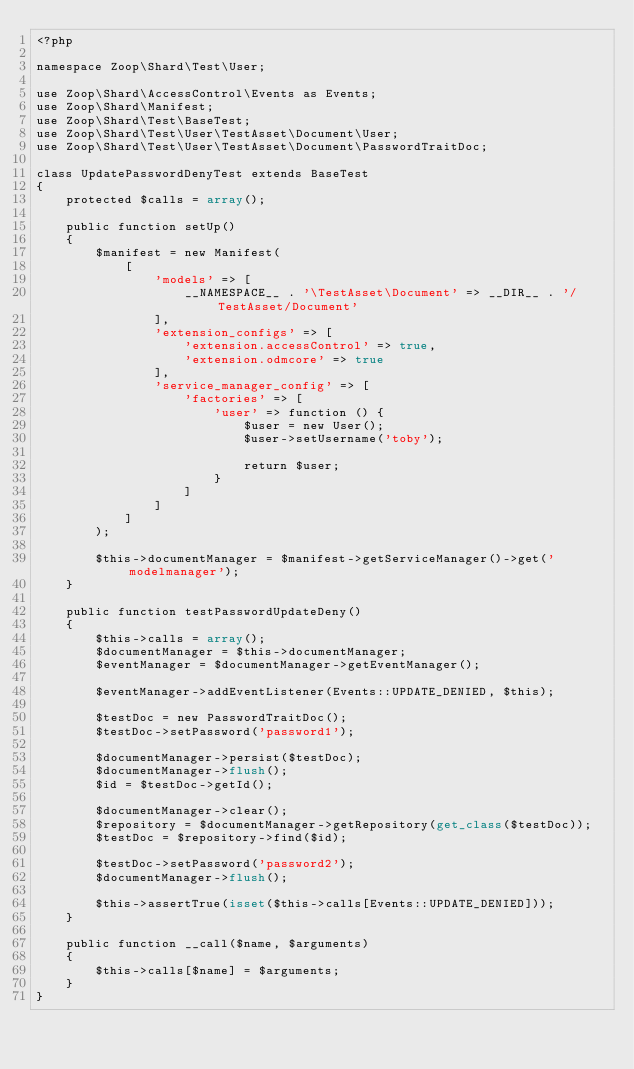<code> <loc_0><loc_0><loc_500><loc_500><_PHP_><?php

namespace Zoop\Shard\Test\User;

use Zoop\Shard\AccessControl\Events as Events;
use Zoop\Shard\Manifest;
use Zoop\Shard\Test\BaseTest;
use Zoop\Shard\Test\User\TestAsset\Document\User;
use Zoop\Shard\Test\User\TestAsset\Document\PasswordTraitDoc;

class UpdatePasswordDenyTest extends BaseTest
{
    protected $calls = array();

    public function setUp()
    {
        $manifest = new Manifest(
            [
                'models' => [
                    __NAMESPACE__ . '\TestAsset\Document' => __DIR__ . '/TestAsset/Document'
                ],
                'extension_configs' => [
                    'extension.accessControl' => true,
                    'extension.odmcore' => true
                ],
                'service_manager_config' => [
                    'factories' => [
                        'user' => function () {
                            $user = new User();
                            $user->setUsername('toby');

                            return $user;
                        }
                    ]
                ]
            ]
        );

        $this->documentManager = $manifest->getServiceManager()->get('modelmanager');
    }

    public function testPasswordUpdateDeny()
    {
        $this->calls = array();
        $documentManager = $this->documentManager;
        $eventManager = $documentManager->getEventManager();

        $eventManager->addEventListener(Events::UPDATE_DENIED, $this);

        $testDoc = new PasswordTraitDoc();
        $testDoc->setPassword('password1');

        $documentManager->persist($testDoc);
        $documentManager->flush();
        $id = $testDoc->getId();

        $documentManager->clear();
        $repository = $documentManager->getRepository(get_class($testDoc));
        $testDoc = $repository->find($id);

        $testDoc->setPassword('password2');
        $documentManager->flush();

        $this->assertTrue(isset($this->calls[Events::UPDATE_DENIED]));
    }

    public function __call($name, $arguments)
    {
        $this->calls[$name] = $arguments;
    }
}
</code> 